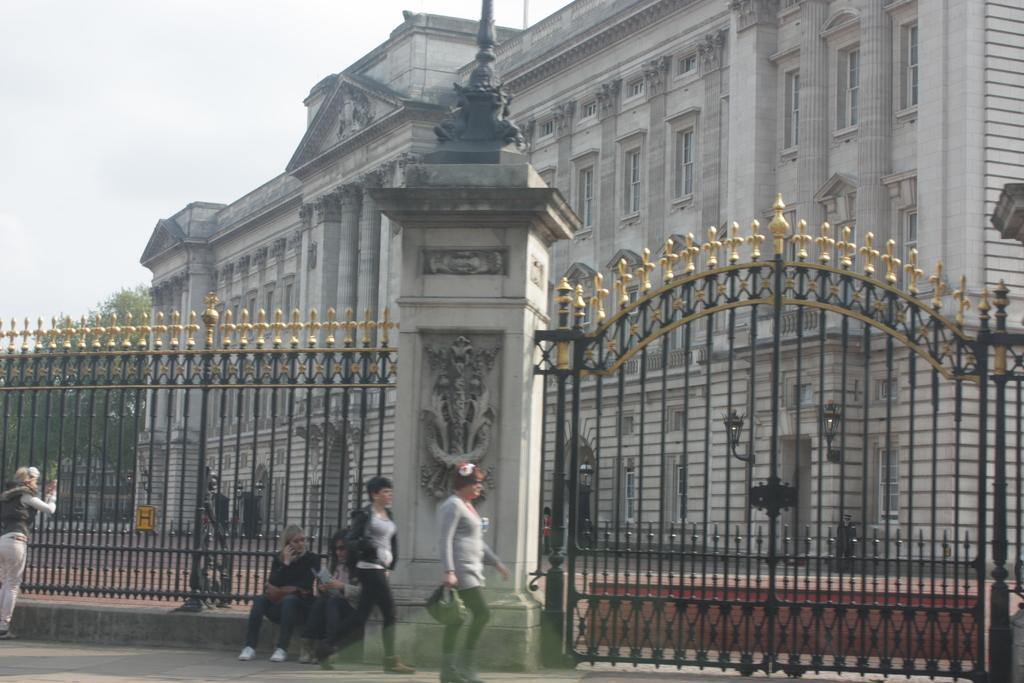What type of structures can be seen in the image? There are buildings in the image. What architectural elements are present in the image? There are pillars in the image. What artistic features can be seen in the image? There are statues in the image. What are the people in the image doing? There are persons sitting on the pavement and persons walking on the road in the image. What type of signage is present in the image? There are sign boards in the image. What type of lighting is present in the image? There are street lights in the image. What type of entrance or exit is present in the image? There are gates in the image. What part of the natural environment is visible in the image? The sky is visible in the image. What type of pie is being served at the cent in the image? There is no cent or pie present in the image. What team is playing in the image? There is no team or game being played in the image. 